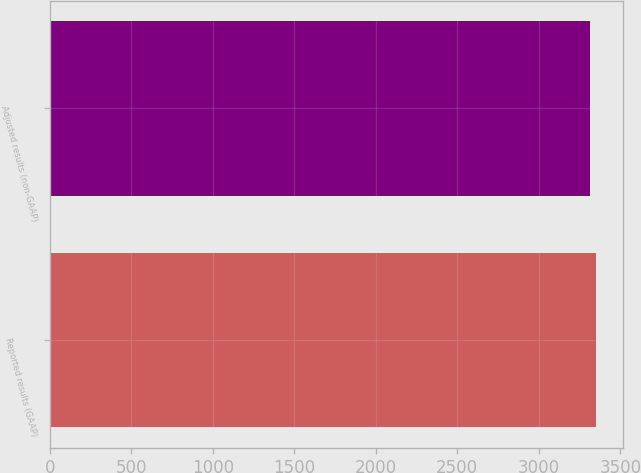Convert chart to OTSL. <chart><loc_0><loc_0><loc_500><loc_500><bar_chart><fcel>Reported results (GAAP)<fcel>Adjusted results (non-GAAP)<nl><fcel>3352<fcel>3316<nl></chart> 